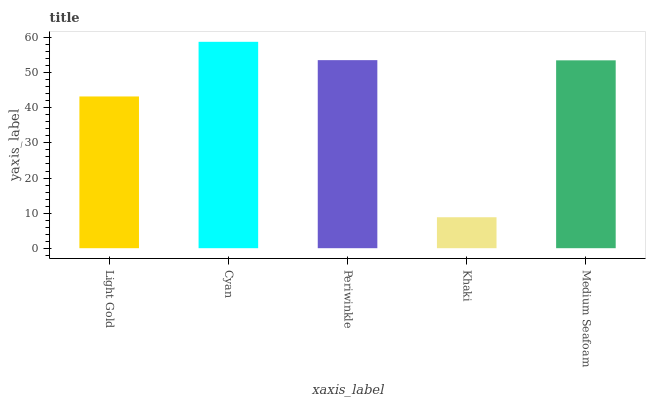Is Khaki the minimum?
Answer yes or no. Yes. Is Cyan the maximum?
Answer yes or no. Yes. Is Periwinkle the minimum?
Answer yes or no. No. Is Periwinkle the maximum?
Answer yes or no. No. Is Cyan greater than Periwinkle?
Answer yes or no. Yes. Is Periwinkle less than Cyan?
Answer yes or no. Yes. Is Periwinkle greater than Cyan?
Answer yes or no. No. Is Cyan less than Periwinkle?
Answer yes or no. No. Is Medium Seafoam the high median?
Answer yes or no. Yes. Is Medium Seafoam the low median?
Answer yes or no. Yes. Is Khaki the high median?
Answer yes or no. No. Is Khaki the low median?
Answer yes or no. No. 